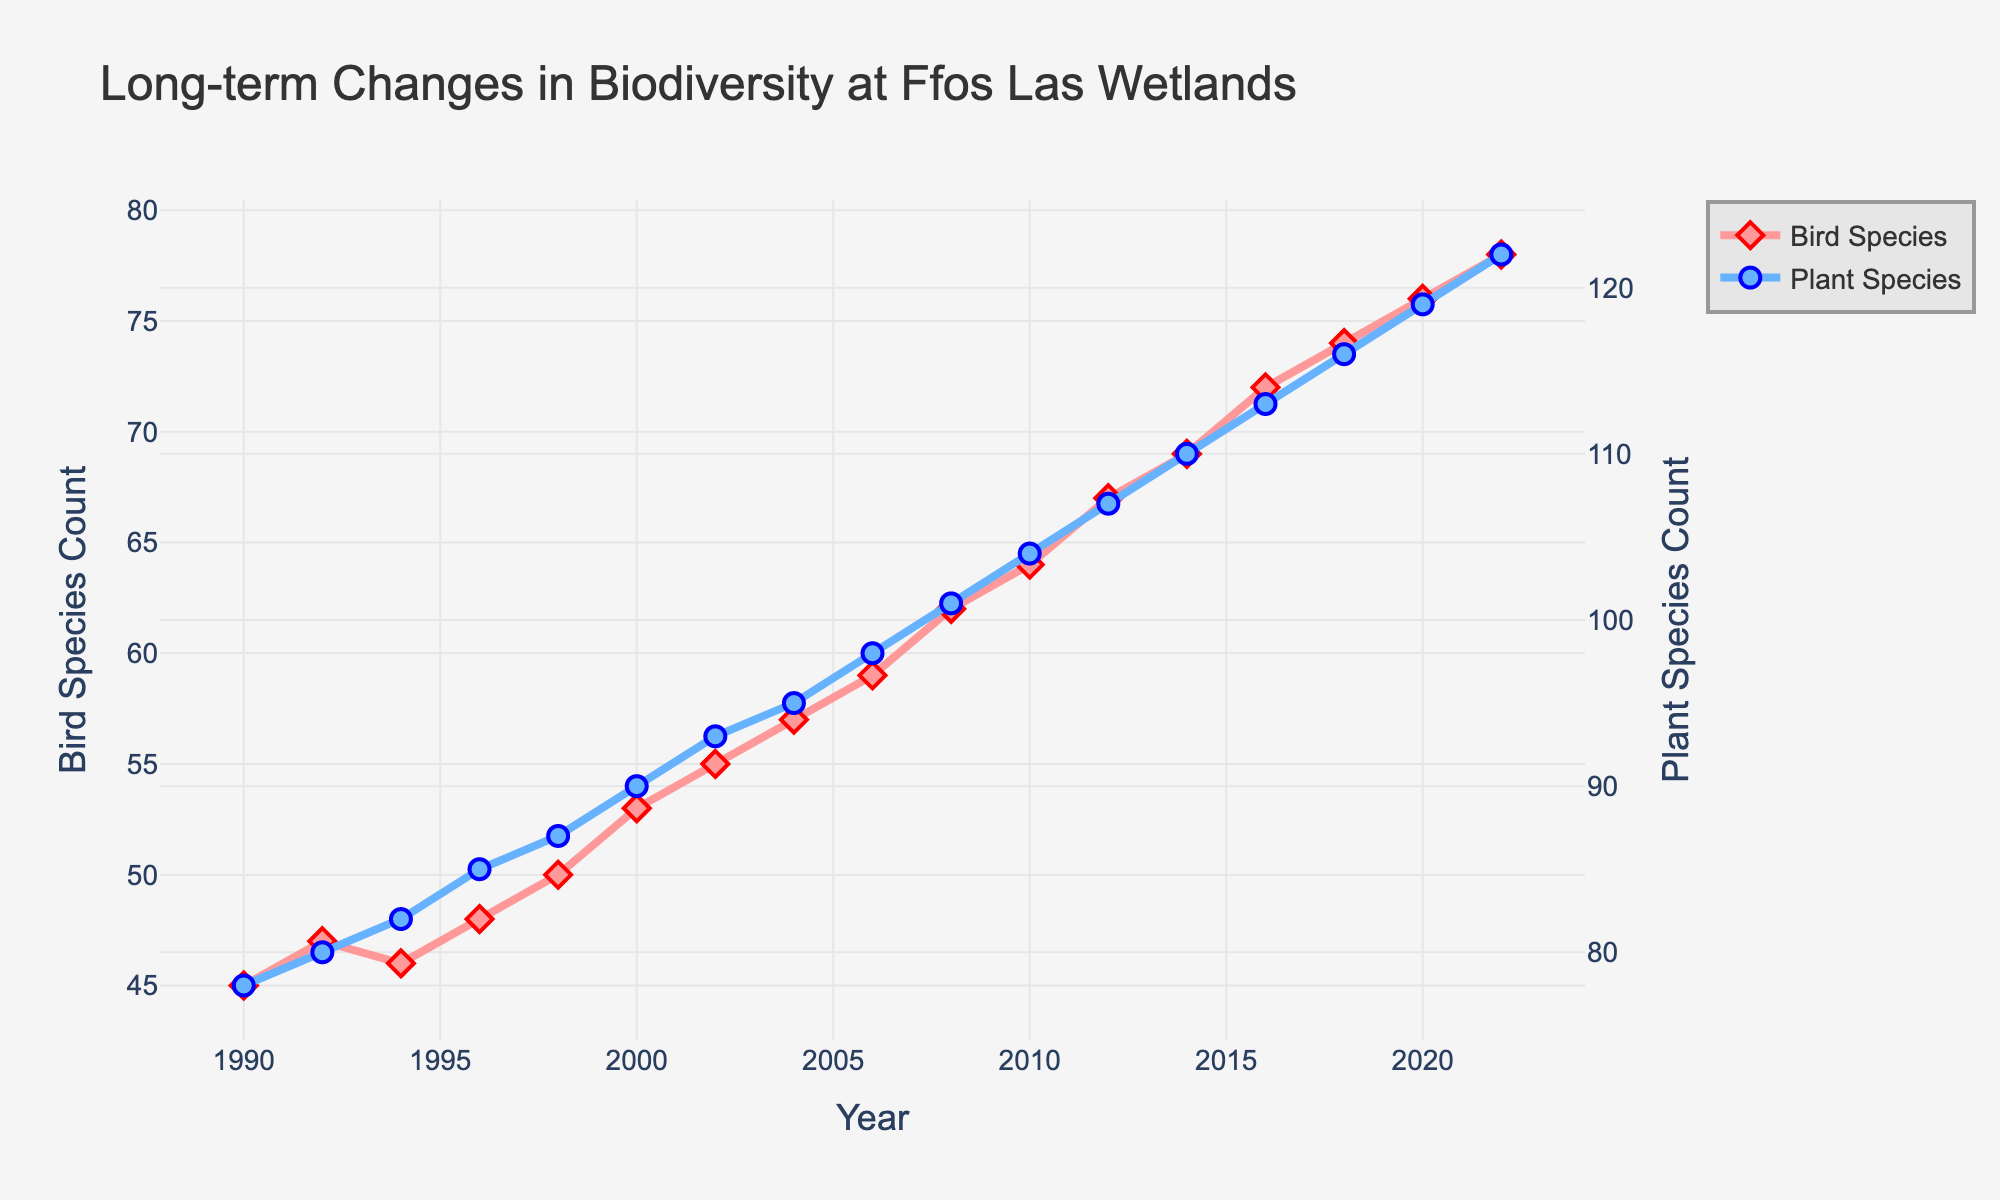What is the trend in the Bird Species Count from 1990 to 2022? The Bird Species Count shows a consistent, upward trend from 1990 with 45 species to 2022 with 78 species.
Answer: Upward trend Which year saw a higher count in Bird Species, 2000 or 2002? In 2000, the Bird Species count was 53, while in 2002, it increased to 55. Therefore, 2002 saw a higher count.
Answer: 2002 How many more Plant Species were there in 2016 compared to 2008? In 2008, there were 101 Plant Species, and by 2016, the count rose to 113. The difference is 113 - 101 = 12 species.
Answer: 12 species What was the increase in both Bird and Plant Species Count from 2010 to 2020? Bird Species Count increased from 64 in 2010 to 76 in 2020, an increase of 12 (76 - 64). Plant Species Count rose from 104 in 2010 to 119 in 2020, an increase of 15 (119 - 104). Total increase for both is 12 + 15 = 27.
Answer: 27 Between which years did the Bird Species Count show the largest increase? The Bird Species Count increased from 74 in 2018 to 76 in 2020, and from 76 in 2020 to 78 in 2022, both increases of 2. Looking at 2008 to 2010, from 62 to 64, also an increase of 2. However, mid-range comparisons like from 1998 (50) to 2000 (53) show an increase of 3, and from 2014 (69) to 2016 (72) also gives an increase of 3. So the largest apparent increase is 3.
Answer: 3 (multiple years) What visual features distinguish the Bird Species and Plant Species lines on the chart? The Bird Species line is red, thicker, and marked with diamond symbols, while the Plant Species line is blue, also thick but marked with circular symbols.
Answer: Color, thickness, symbols When did the Plant Species Count reach 100, and what was the corresponding Bird Species Count at that time? The Plant Species Count reached 100 between 2008 (101) and 2006 (98). By 2008, corresponding Bird Species Count was 62.
Answer: 2008, 62 species What is the average increase in Plant Species Count per year from 1990 to 2022? Total increase in Plant Species Count from 1990 (78) to 2022 (122) is 122 - 78 = 44. Spread this over 2022 - 1990 = 32 years, so average increase is 44 / 32 = 1.375 per year.
Answer: 1.375 per year Which year had the highest counts for both Bird Species and Plant Species combined? In 2022, Bird Species Count was 78 and Plant Species Count was 122, totaling 78 + 122 = 200, the highest combined count.
Answer: 2022 